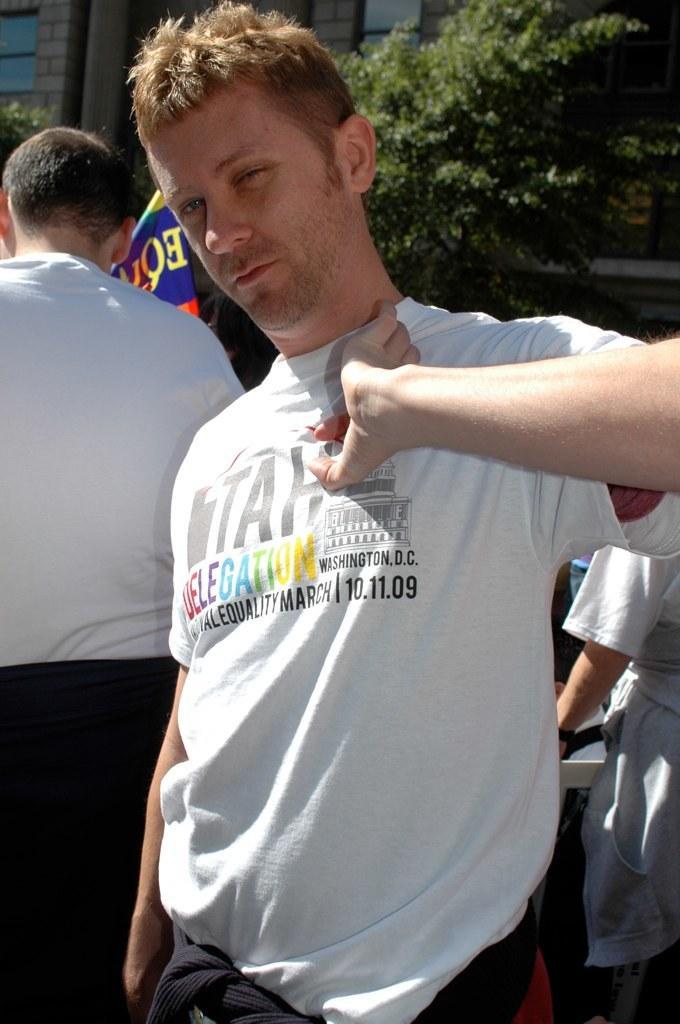In one or two sentences, can you explain what this image depicts? This image consists of three persons. They are wearing white T-shirts. In the background, we can see a building along with the tree. 